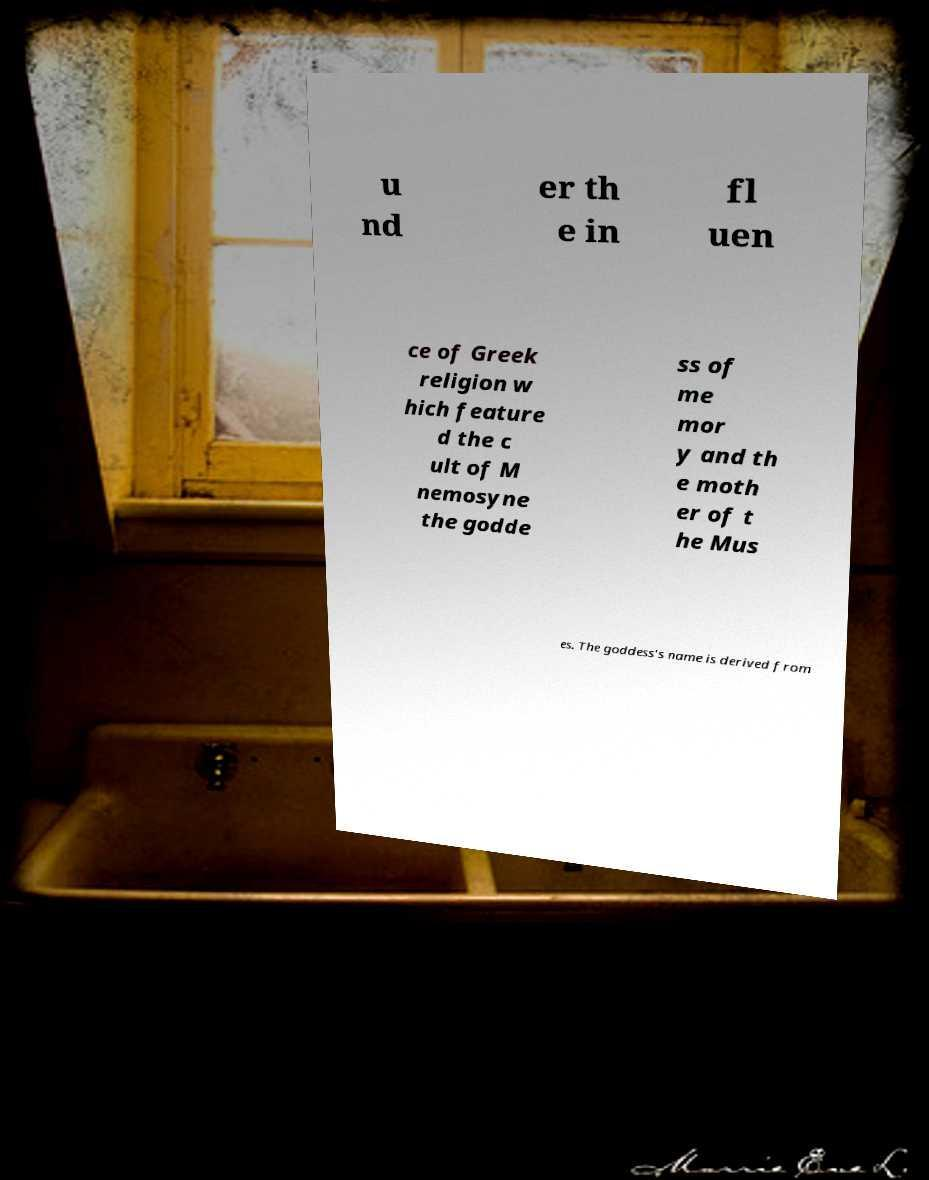I need the written content from this picture converted into text. Can you do that? u nd er th e in fl uen ce of Greek religion w hich feature d the c ult of M nemosyne the godde ss of me mor y and th e moth er of t he Mus es. The goddess's name is derived from 